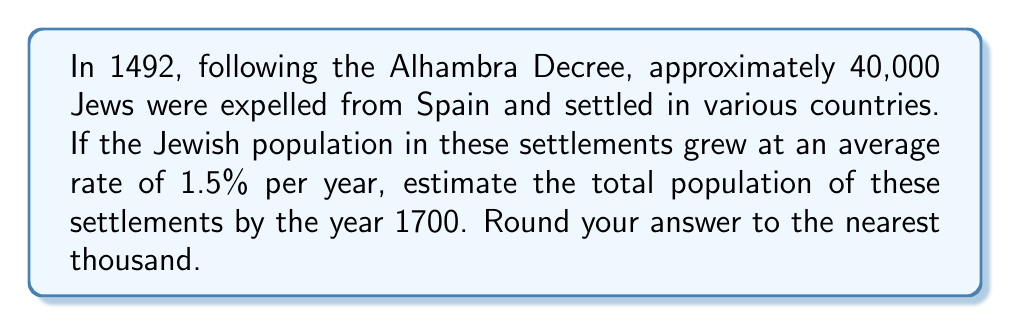Can you answer this question? To solve this problem, we need to use the compound interest formula, which is also applicable to population growth:

$$ A = P(1 + r)^t $$

Where:
$A$ = Final amount (population)
$P$ = Initial principal balance (initial population)
$r$ = Annual interest (growth) rate
$t$ = Number of years

Given:
$P = 40,000$ (initial population in 1492)
$r = 1.5\% = 0.015$ (annual growth rate)
$t = 1700 - 1492 = 208$ years

Let's plug these values into the formula:

$$ A = 40,000(1 + 0.015)^{208} $$

Using a calculator or computer:

$$ A = 40,000 \times 22.1172 $$
$$ A = 884,688 $$

Rounding to the nearest thousand:

$$ A \approx 885,000 $$

This calculation assumes a constant growth rate over the entire period, which is a simplification. In reality, growth rates would have varied due to factors such as migration, wars, economic conditions, and local policies affecting Jewish communities.
Answer: 885,000 